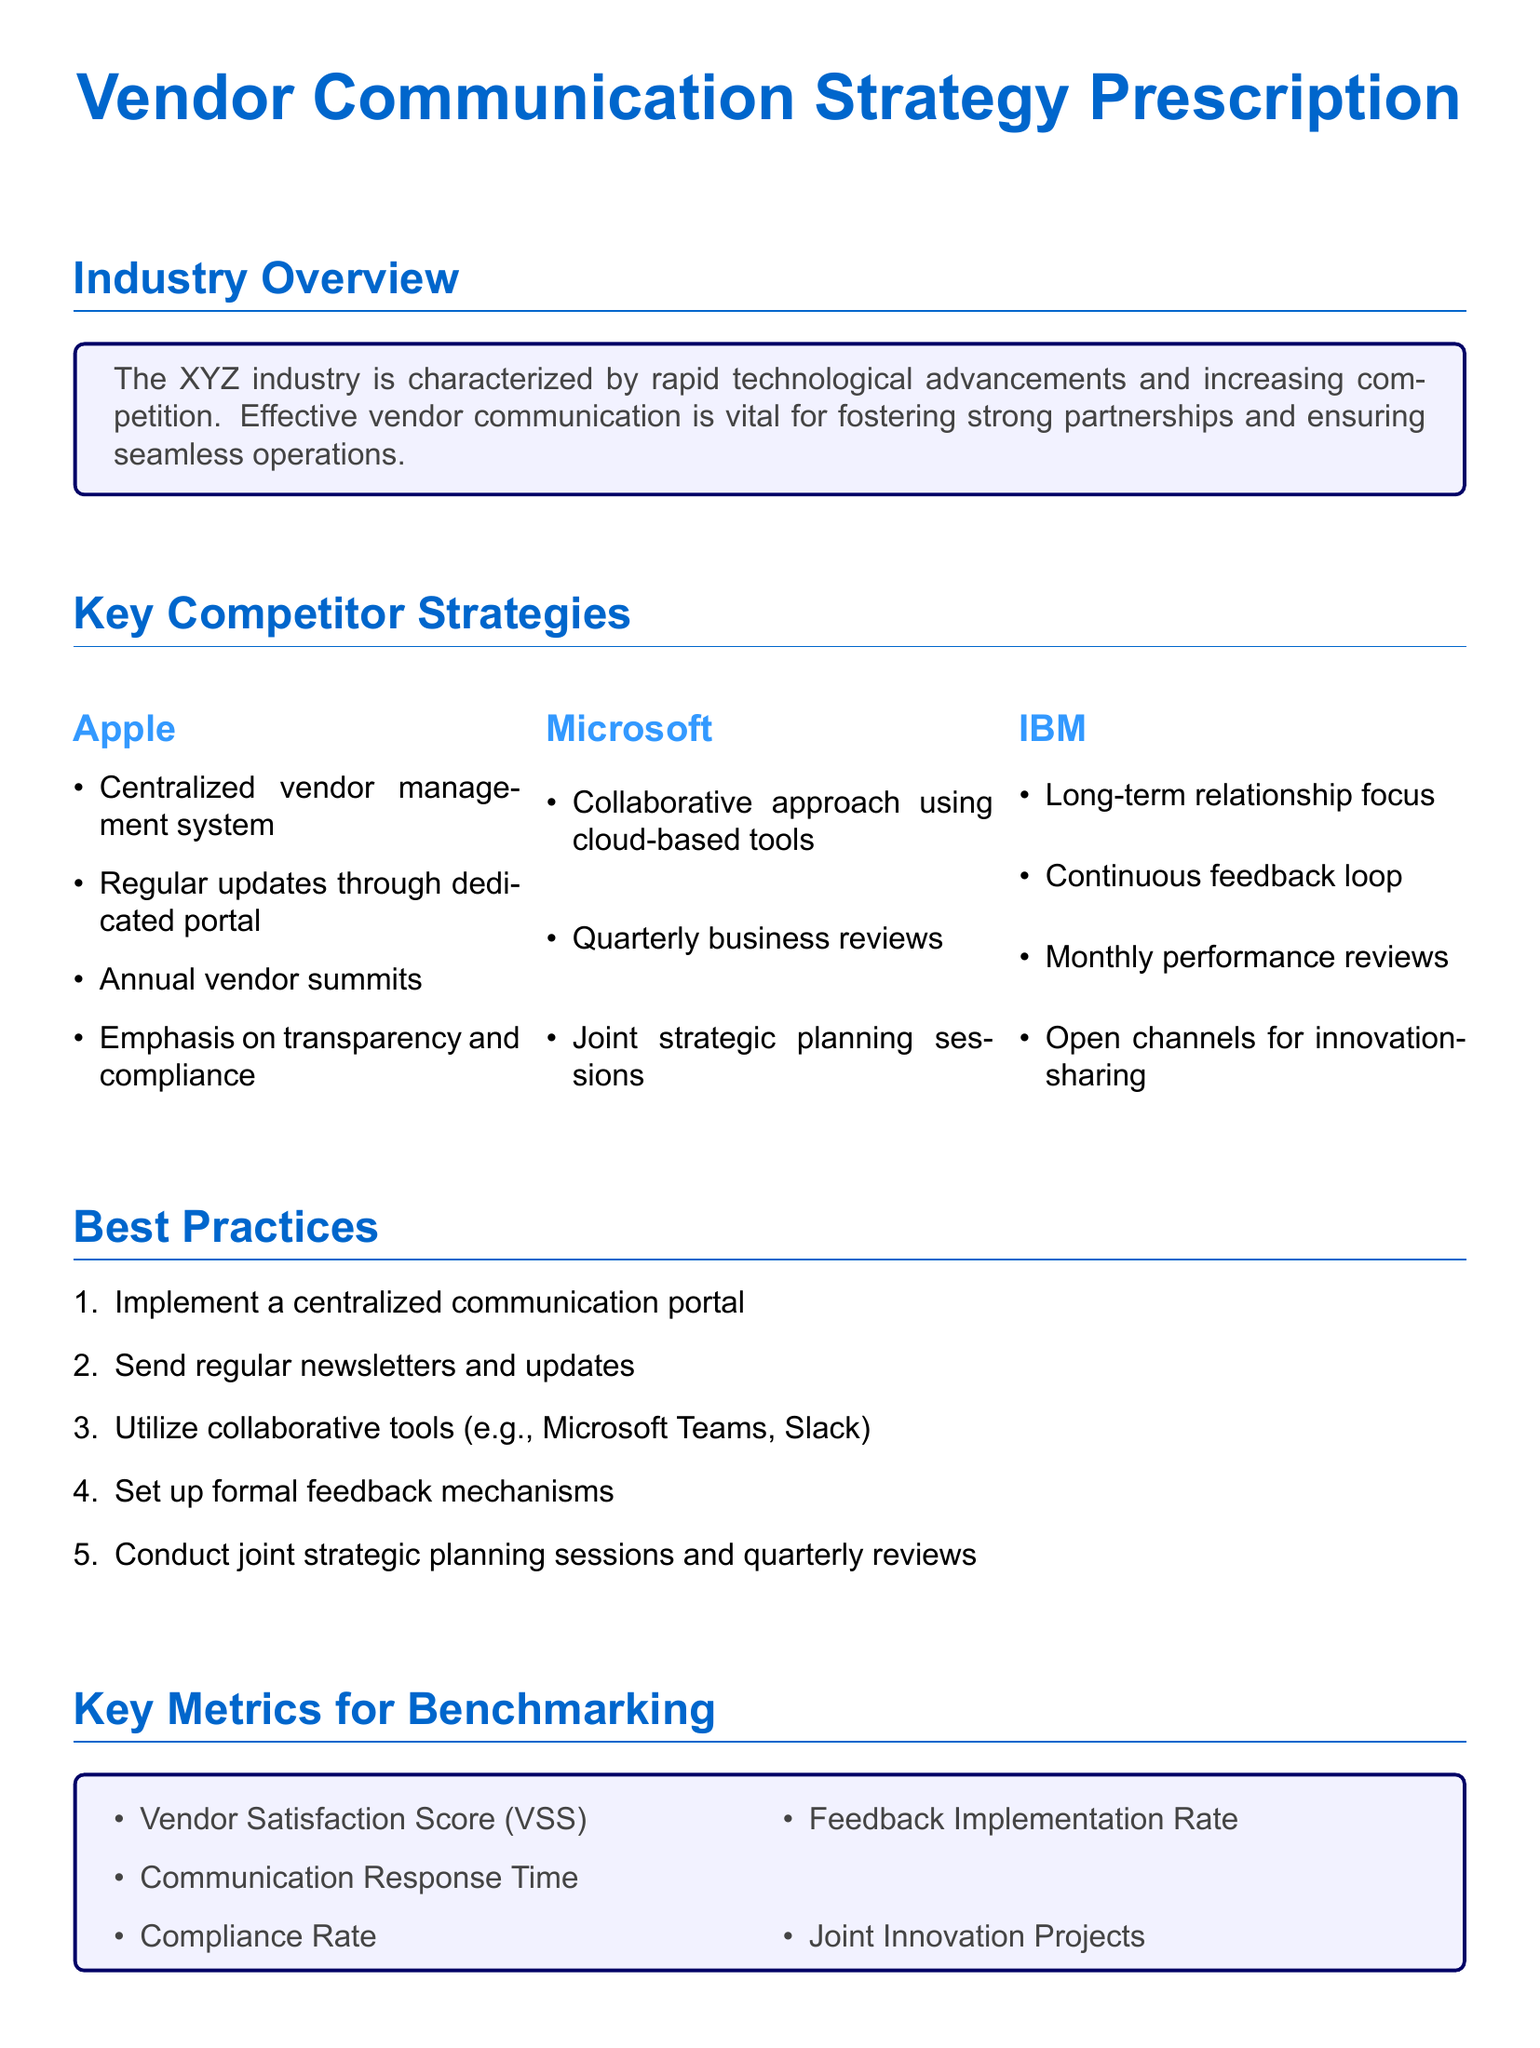What is the main purpose of the document? The document outlines strategies for improving vendor communication in our industry, focusing on competitive benchmarking analysis.
Answer: vendor communication strategy How many key competitor strategies are listed? The document presents competitor strategies from three companies: Apple, Microsoft, and IBM.
Answer: three What tool does Microsoft utilize for collaboration? Microsoft employs cloud-based tools to facilitate collaboration among vendors.
Answer: cloud-based tools What action is suggested to improve vendor relationships? The document recommends establishing a regular newsletter schedule as part of the action plan.
Answer: regular newsletter schedule Which metric measures vendor satisfaction? The document includes a specific metric called Vendor Satisfaction Score for benchmarking purposes.
Answer: Vendor Satisfaction Score Who holds annual vendor summits? The document states that Apple conducts annual vendor summits as part of its communication strategy.
Answer: Apple What is the frequency of performance reviews suggested by IBM? The document notes that IBM conducts monthly performance reviews to maintain effective communication with vendors.
Answer: monthly What type of planning sessions are recommended in best practices? The document suggests conducting joint strategic planning sessions as a best practice for vendor communication.
Answer: joint strategic planning sessions What is the communication response time classified under? Communication Response Time is listed as one of the key metrics for benchmarking in the document.
Answer: key metrics for benchmarking 